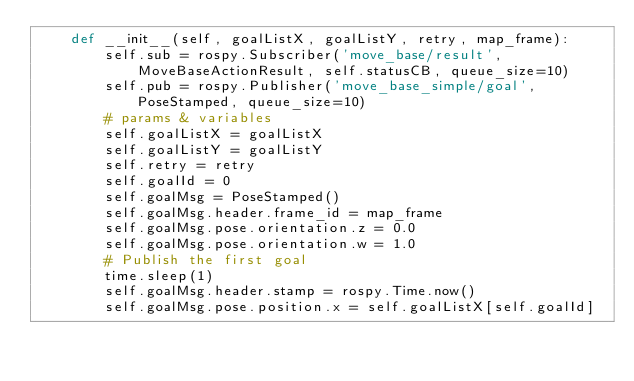Convert code to text. <code><loc_0><loc_0><loc_500><loc_500><_Python_>    def __init__(self, goalListX, goalListY, retry, map_frame):
        self.sub = rospy.Subscriber('move_base/result', MoveBaseActionResult, self.statusCB, queue_size=10)
        self.pub = rospy.Publisher('move_base_simple/goal', PoseStamped, queue_size=10)   
        # params & variables
        self.goalListX = goalListX
        self.goalListY = goalListY
        self.retry = retry
        self.goalId = 0
        self.goalMsg = PoseStamped()
        self.goalMsg.header.frame_id = map_frame
        self.goalMsg.pose.orientation.z = 0.0
        self.goalMsg.pose.orientation.w = 1.0
        # Publish the first goal
        time.sleep(1)
        self.goalMsg.header.stamp = rospy.Time.now()
        self.goalMsg.pose.position.x = self.goalListX[self.goalId]</code> 